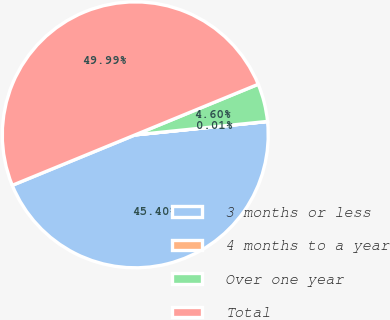Convert chart. <chart><loc_0><loc_0><loc_500><loc_500><pie_chart><fcel>3 months or less<fcel>4 months to a year<fcel>Over one year<fcel>Total<nl><fcel>45.4%<fcel>0.01%<fcel>4.6%<fcel>49.99%<nl></chart> 